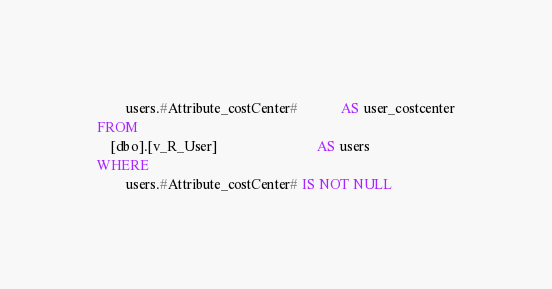<code> <loc_0><loc_0><loc_500><loc_500><_SQL_>		users.#Attribute_costCenter#			AS user_costcenter
FROM
	[dbo].[v_R_User]							AS users
WHERE
        users.#Attribute_costCenter# IS NOT NULL</code> 